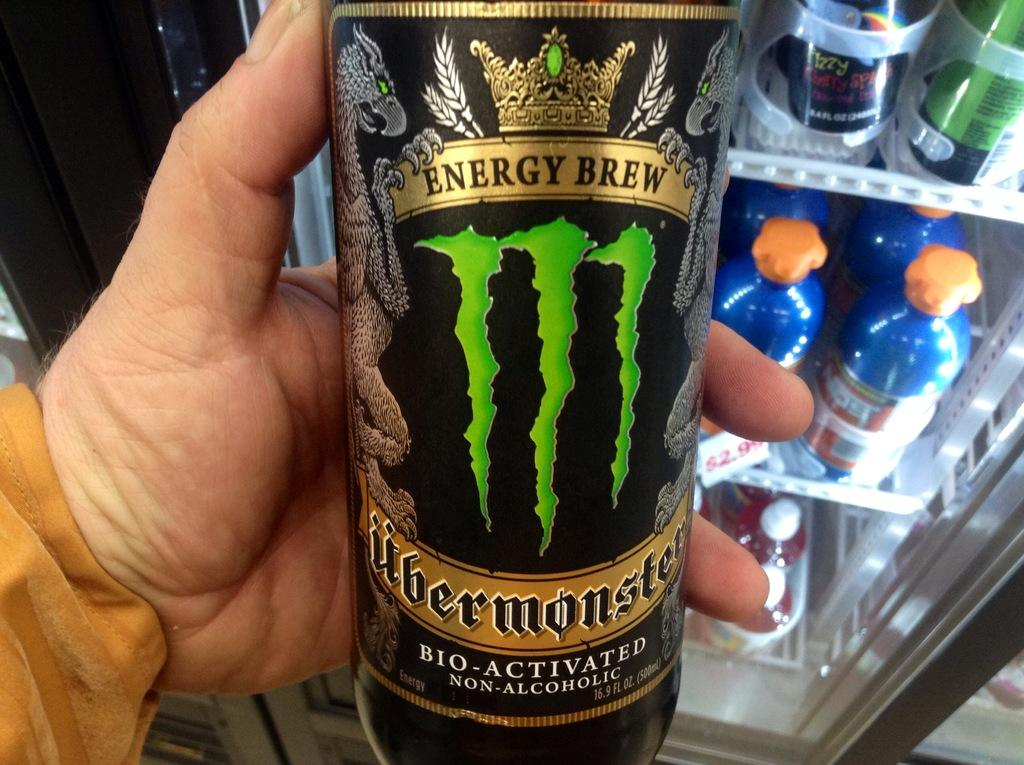What is the guy holding in the image? The guy is holding a glass bottle in the image. What is the name of the bottle? The bottle is named "Uber Monster." What can be seen in the background of the image? There is a refrigerator in the background of the image. What is inside the refrigerator? The refrigerator is filled with bottles. What type of brain is visible in the image? There is no brain visible in the image. What suggestion does the guy holding the bottle have for the viewer? The provided facts do not mention any suggestions from the guy holding the bottle, so it cannot be determined from the image. 